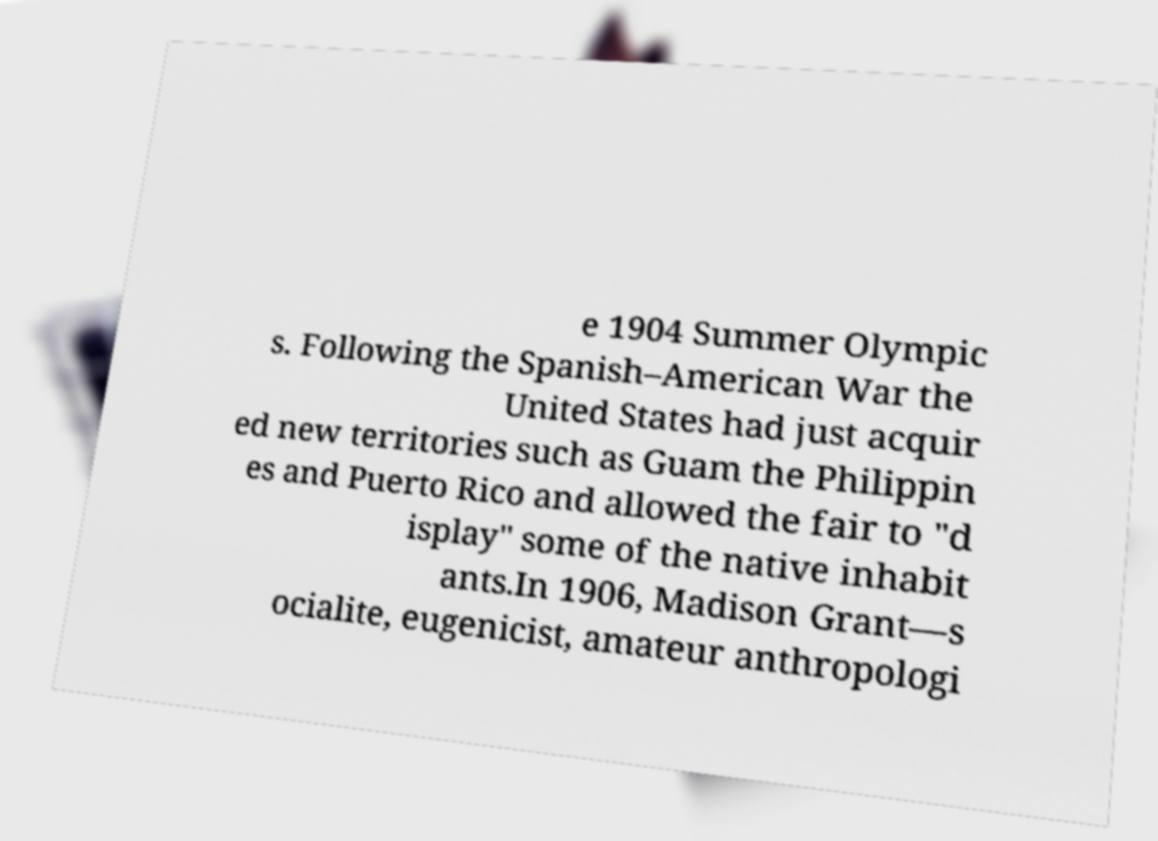Please identify and transcribe the text found in this image. e 1904 Summer Olympic s. Following the Spanish–American War the United States had just acquir ed new territories such as Guam the Philippin es and Puerto Rico and allowed the fair to "d isplay" some of the native inhabit ants.In 1906, Madison Grant—s ocialite, eugenicist, amateur anthropologi 